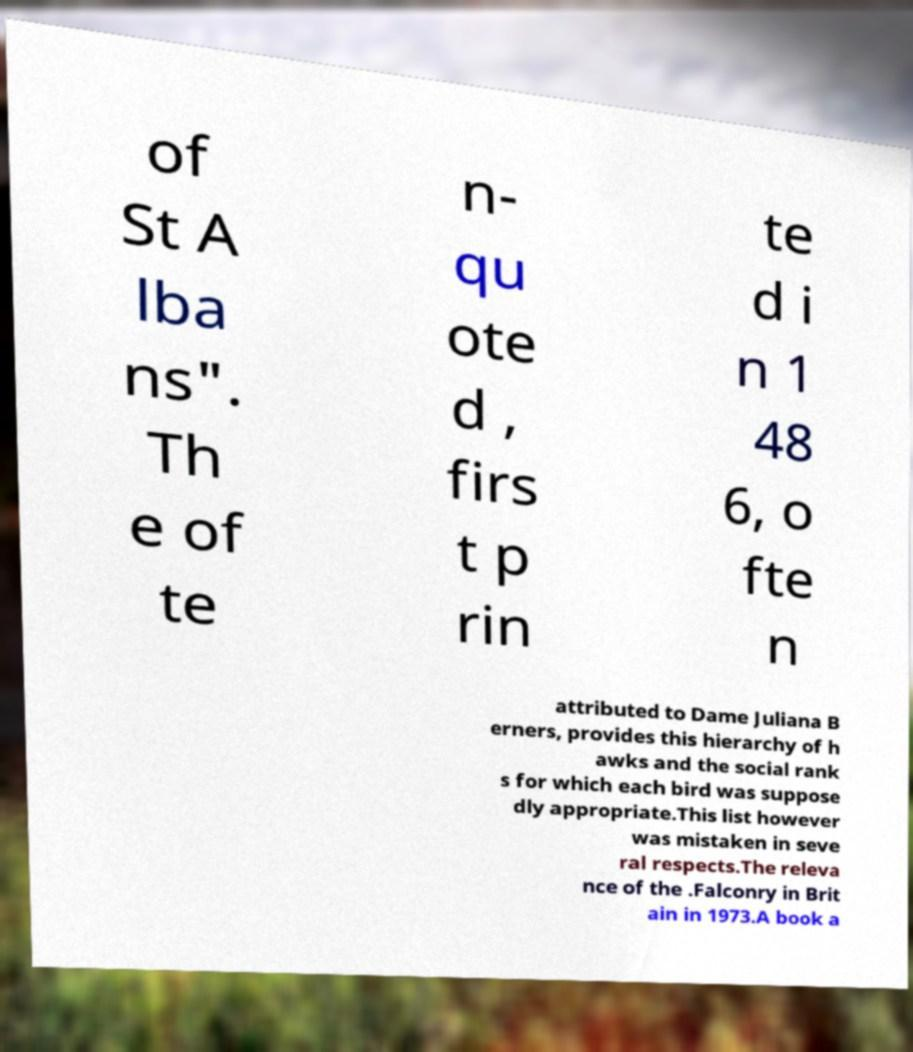What messages or text are displayed in this image? I need them in a readable, typed format. of St A lba ns". Th e of te n- qu ote d , firs t p rin te d i n 1 48 6, o fte n attributed to Dame Juliana B erners, provides this hierarchy of h awks and the social rank s for which each bird was suppose dly appropriate.This list however was mistaken in seve ral respects.The releva nce of the .Falconry in Brit ain in 1973.A book a 